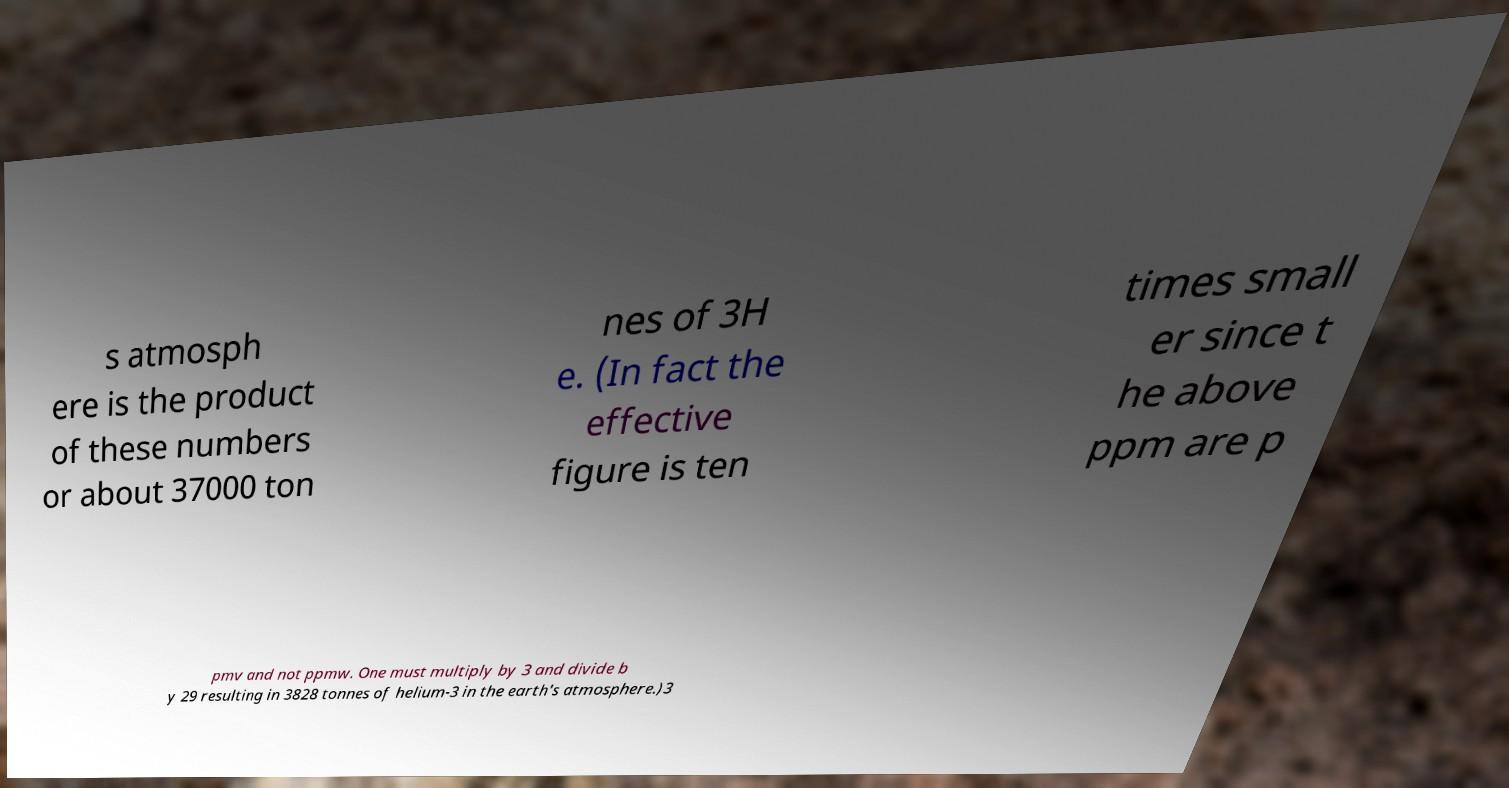Please read and relay the text visible in this image. What does it say? s atmosph ere is the product of these numbers or about 37000 ton nes of 3H e. (In fact the effective figure is ten times small er since t he above ppm are p pmv and not ppmw. One must multiply by 3 and divide b y 29 resulting in 3828 tonnes of helium-3 in the earth's atmosphere.)3 